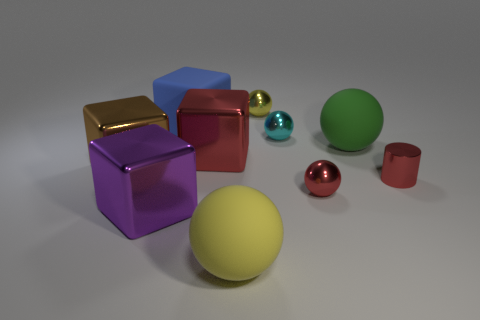What material is the large blue thing that is the same shape as the big purple object?
Your response must be concise. Rubber. The big matte cube is what color?
Keep it short and to the point. Blue. What color is the matte ball that is right of the large matte sphere that is in front of the big green matte ball?
Provide a short and direct response. Green. There is a small metallic cylinder; is it the same color as the shiny sphere in front of the green rubber thing?
Your answer should be compact. Yes. There is a object that is behind the cube that is behind the green matte object; how many blue rubber things are behind it?
Offer a terse response. 0. There is a red shiny block; are there any tiny red metallic cylinders right of it?
Your answer should be compact. Yes. Are there any other things that have the same color as the small cylinder?
Ensure brevity in your answer.  Yes. What number of spheres are either cyan shiny things or brown metal objects?
Your answer should be compact. 1. How many big things are both left of the tiny cyan ball and behind the metallic cylinder?
Provide a short and direct response. 3. Is the number of brown metal cubes behind the small cyan sphere the same as the number of small yellow metal things to the right of the rubber cube?
Keep it short and to the point. No. 